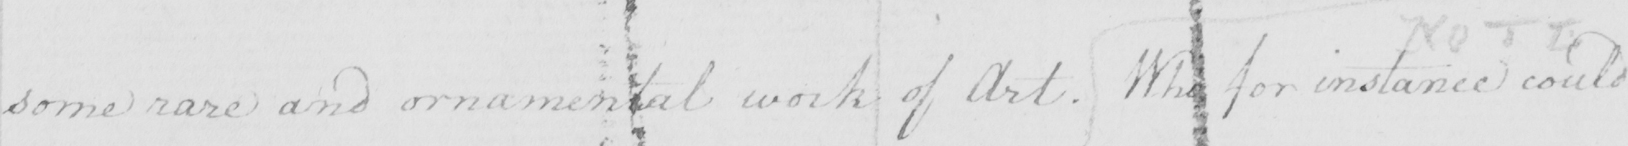What does this handwritten line say? some rare and ornamental work of Art . Who for instance could 